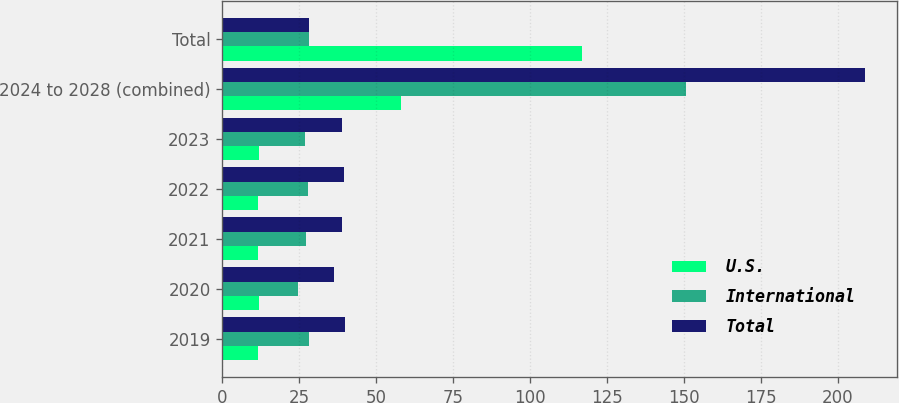<chart> <loc_0><loc_0><loc_500><loc_500><stacked_bar_chart><ecel><fcel>2019<fcel>2020<fcel>2021<fcel>2022<fcel>2023<fcel>2024 to 2028 (combined)<fcel>Total<nl><fcel>U.S.<fcel>11.7<fcel>11.8<fcel>11.7<fcel>11.7<fcel>11.8<fcel>58.1<fcel>116.8<nl><fcel>International<fcel>28.2<fcel>24.7<fcel>27.2<fcel>27.8<fcel>27<fcel>150.9<fcel>28.2<nl><fcel>Total<fcel>39.9<fcel>36.5<fcel>38.9<fcel>39.5<fcel>38.8<fcel>209<fcel>28.2<nl></chart> 